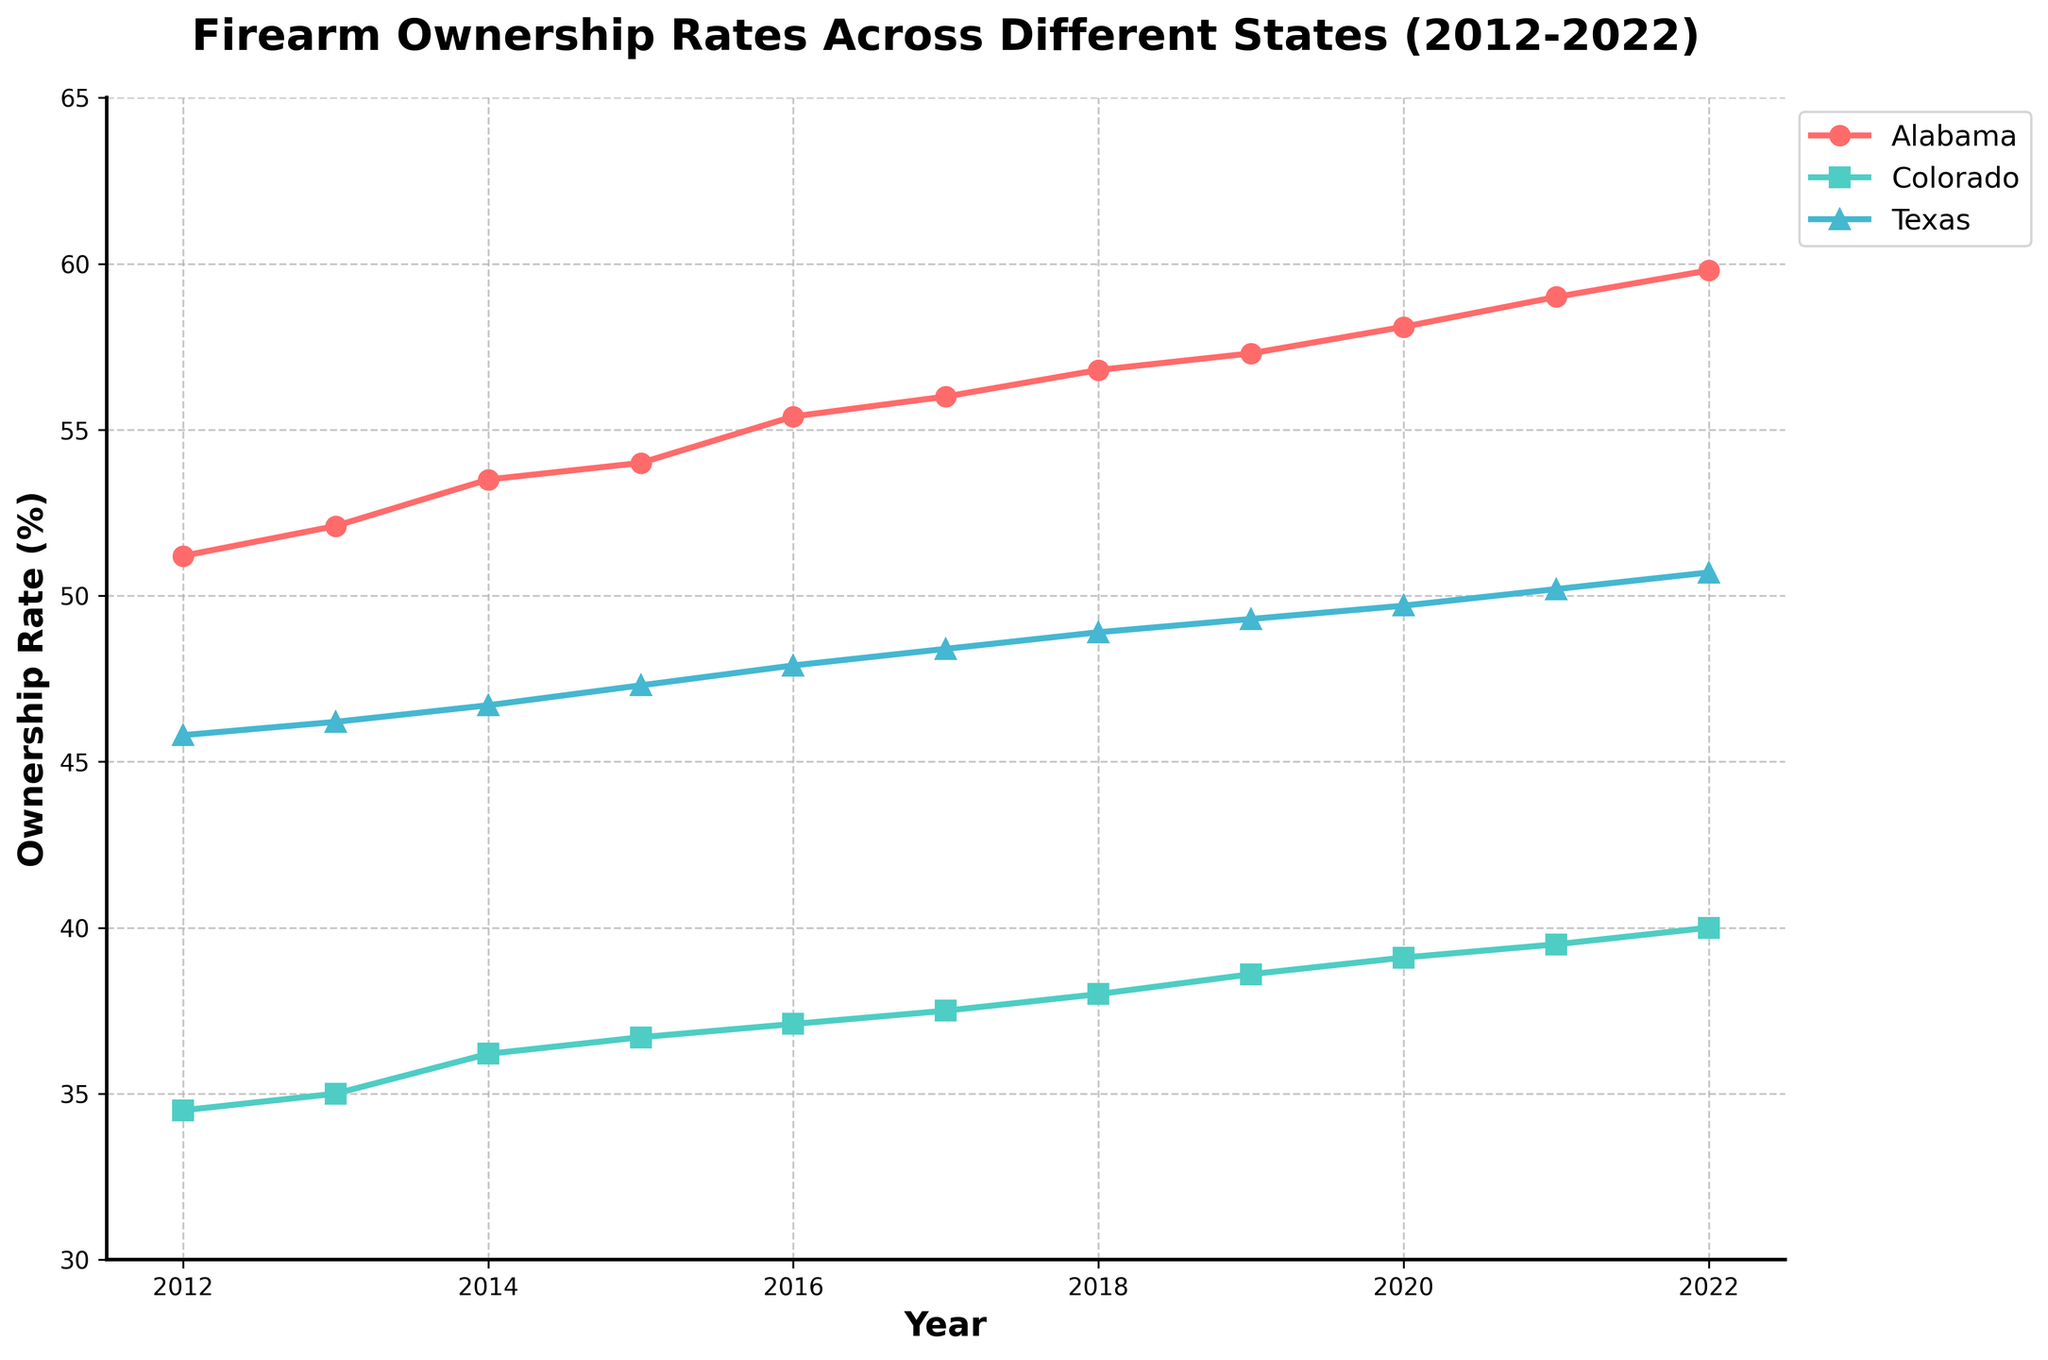What is the title of the figure? The title of the figure is usually found at the top of the plot or chart and provides a summary of the data being presented. In this case, the title explicitly states what the time series plot is about.
Answer: Firearm Ownership Rates Across Different States (2012-2022) What is the ownership rate of firearms in Texas in 2015? To find the ownership rate for Texas in 2015, locate Texas on the figure, follow the time series line up to the year 2015, and read the ownership rate from the y-axis.
Answer: 47.3% Which state had the highest firearm ownership rate in 2022? To determine which state had the highest ownership rate in 2022, compare the end points (year 2022) of the lines representing each state on the figure. Alabama's line is the highest.
Answer: Alabama How many states are represented in the figure? Count the number of unique lines in the plot, each representing a different state. Each line corresponds to Alabama, Colorado, or Texas.
Answer: 3 What is the trend of firearm ownership rates in Alabama over the years? Examine the plot line corresponding to Alabama over the span from 2012 to 2022. The trend shows a steady increase in ownership rates over the years.
Answer: Increasing By how much did the firearm ownership rate in Colorado increase from 2012 to 2022? Calculate the difference between the ownership rates of Colorado in 2022 and 2012. The rates are 40.0% in 2022 and 34.5% in 2012. Therefore, the increase is 40.0% - 34.5%.
Answer: 5.5% Which state shows the smallest increase in firearm ownership rates over the decade? To find the state with the smallest increase, compare the differences between the ownership rates in 2022 and 2012 for all states. Colorado shows the smallest increase (5.5%).
Answer: Colorado In which year did Alabama's ownership rate surpass 55%? Look for the point in the plot where Alabama's line crosses the 55% threshold. Identify the corresponding year from the x-axis.
Answer: 2016 How does the firearm ownership trend in Texas compare to that in Colorado? By examining the slopes of the lines for Texas and Colorado, observe that both states show an increasing trend, but Texas's rate increases more sharply compared to Colorado's.
Answer: Texas's rate increases more sharply Which year shows the largest increase in firearm ownership rates for Colorado? Look for the steepest segment in the plot representing Colorado's ownership trend and note the corresponding year. This typically occurs between two adjacent years where the rate change is largest. Compare annual increases and find that it is between 2018 and 2019, where the rate increases from 38.0% to 38.6%.
Answer: 2019 